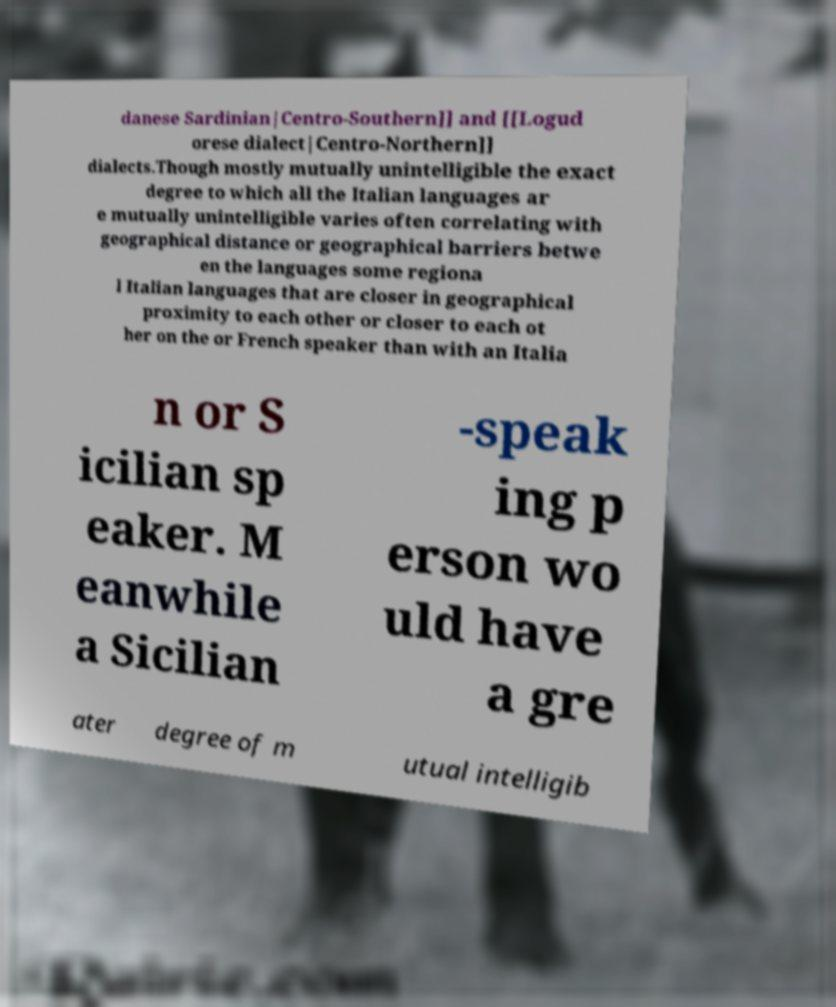Can you read and provide the text displayed in the image?This photo seems to have some interesting text. Can you extract and type it out for me? danese Sardinian|Centro-Southern]] and [[Logud orese dialect|Centro-Northern]] dialects.Though mostly mutually unintelligible the exact degree to which all the Italian languages ar e mutually unintelligible varies often correlating with geographical distance or geographical barriers betwe en the languages some regiona l Italian languages that are closer in geographical proximity to each other or closer to each ot her on the or French speaker than with an Italia n or S icilian sp eaker. M eanwhile a Sicilian -speak ing p erson wo uld have a gre ater degree of m utual intelligib 